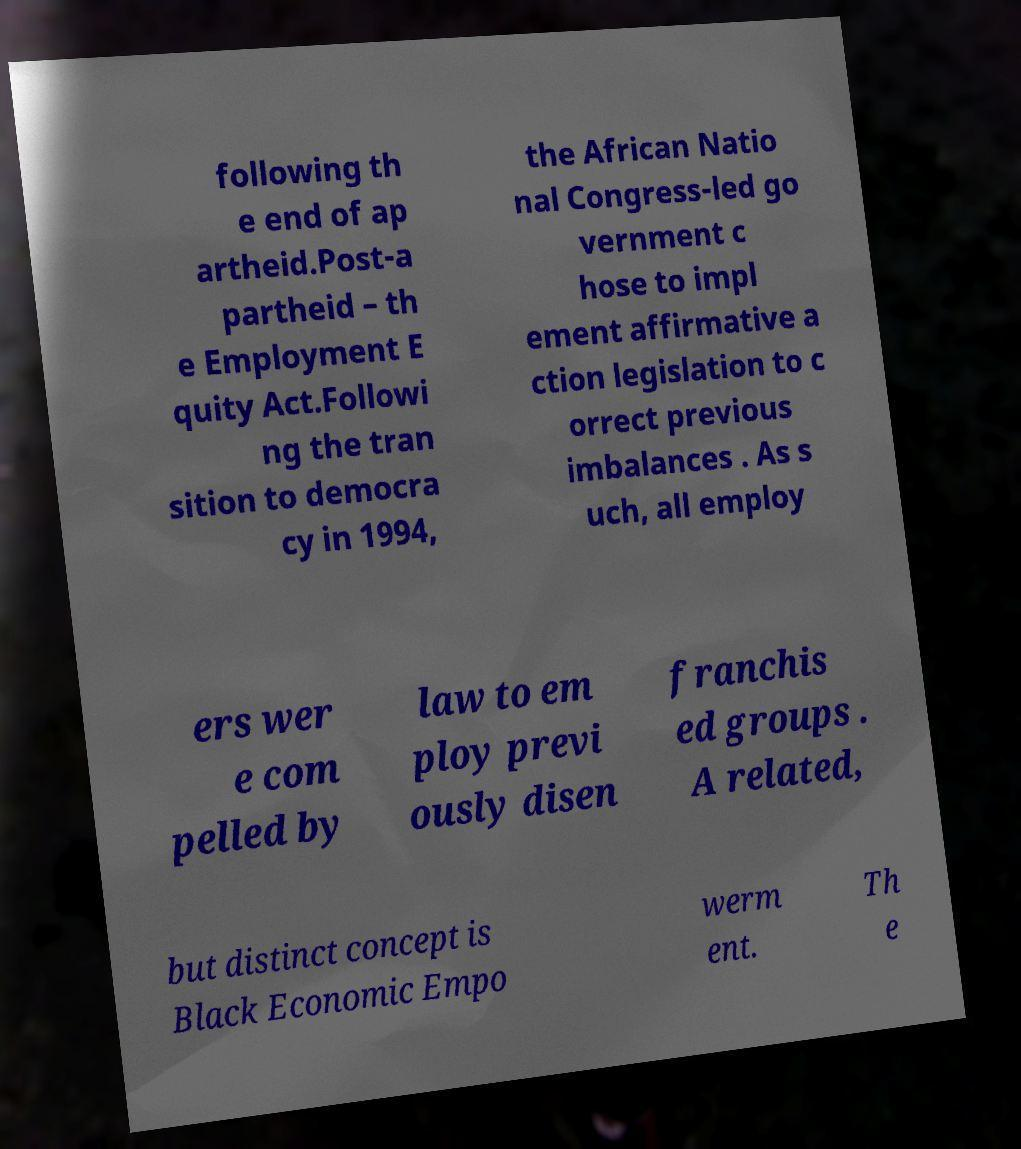Could you assist in decoding the text presented in this image and type it out clearly? following th e end of ap artheid.Post-a partheid – th e Employment E quity Act.Followi ng the tran sition to democra cy in 1994, the African Natio nal Congress-led go vernment c hose to impl ement affirmative a ction legislation to c orrect previous imbalances . As s uch, all employ ers wer e com pelled by law to em ploy previ ously disen franchis ed groups . A related, but distinct concept is Black Economic Empo werm ent. Th e 